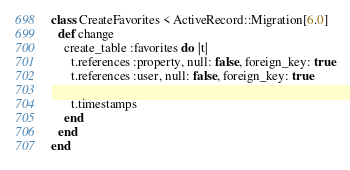<code> <loc_0><loc_0><loc_500><loc_500><_Ruby_>class CreateFavorites < ActiveRecord::Migration[6.0]
  def change
    create_table :favorites do |t|
      t.references :property, null: false, foreign_key: true
      t.references :user, null: false, foreign_key: true

      t.timestamps
    end
  end
end
</code> 